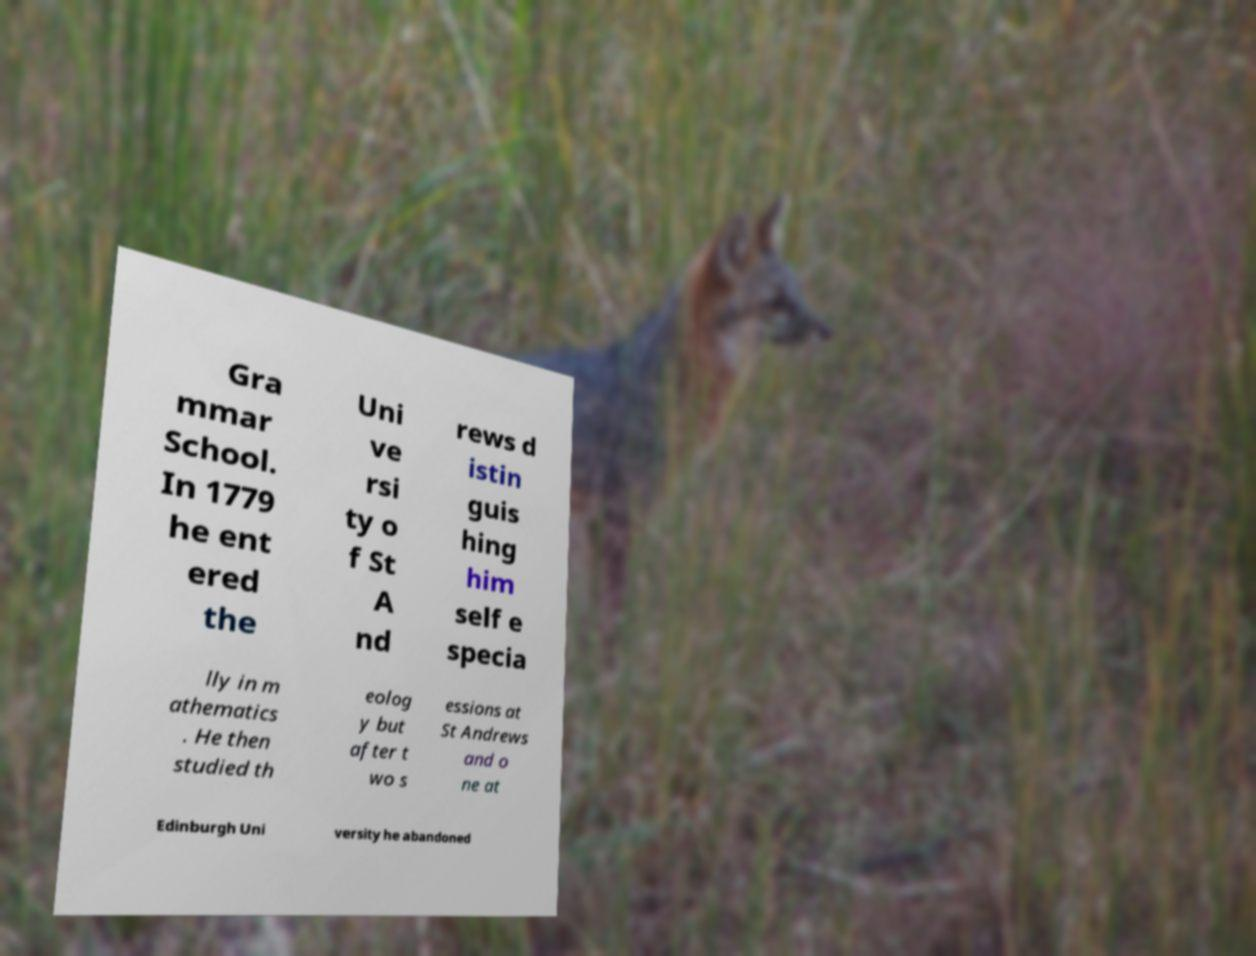For documentation purposes, I need the text within this image transcribed. Could you provide that? Gra mmar School. In 1779 he ent ered the Uni ve rsi ty o f St A nd rews d istin guis hing him self e specia lly in m athematics . He then studied th eolog y but after t wo s essions at St Andrews and o ne at Edinburgh Uni versity he abandoned 